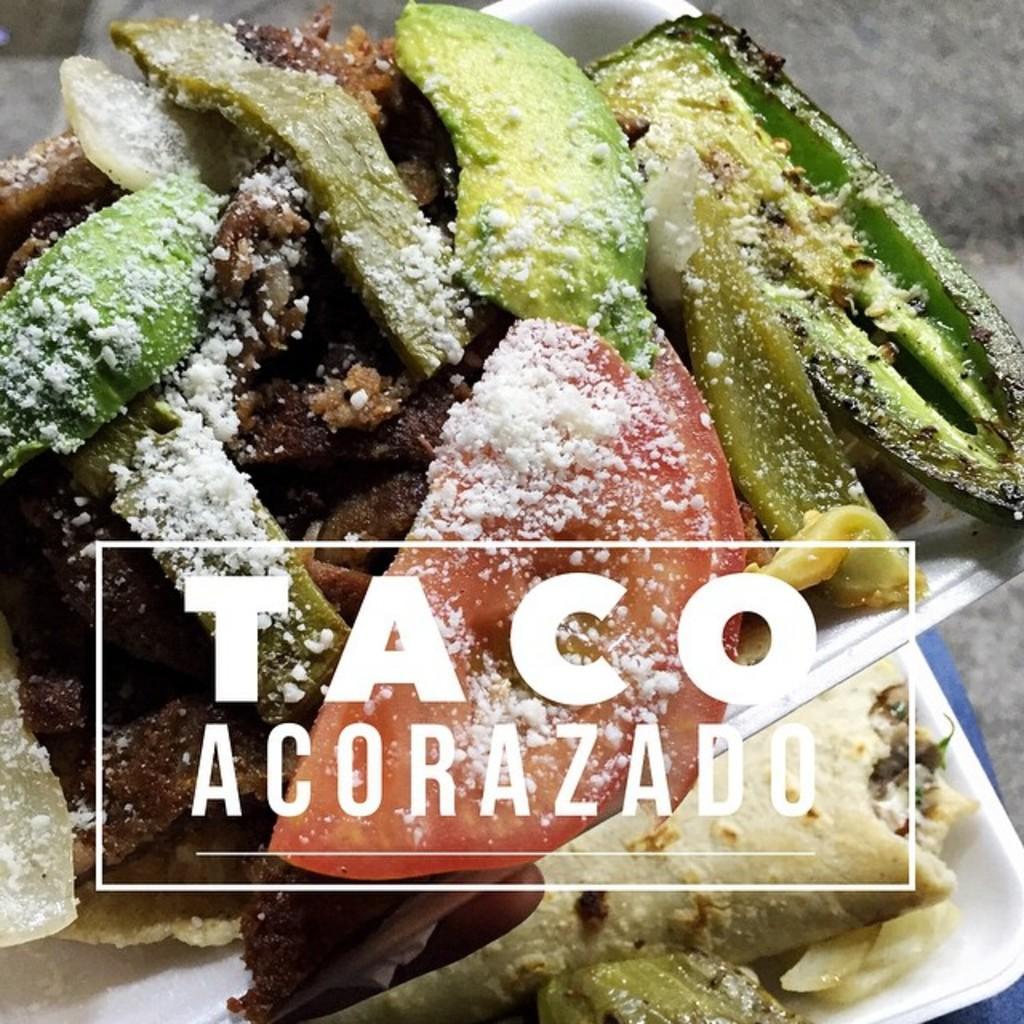Please provide a concise description of this image. There are some food items on tray. On the image something is written. 